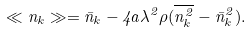Convert formula to latex. <formula><loc_0><loc_0><loc_500><loc_500>\ll n _ { k } \gg = \bar { n } _ { k } - 4 a \lambda ^ { 2 } \rho ( \overline { n ^ { 2 } _ { k } } - \bar { n } ^ { 2 } _ { k } ) .</formula> 